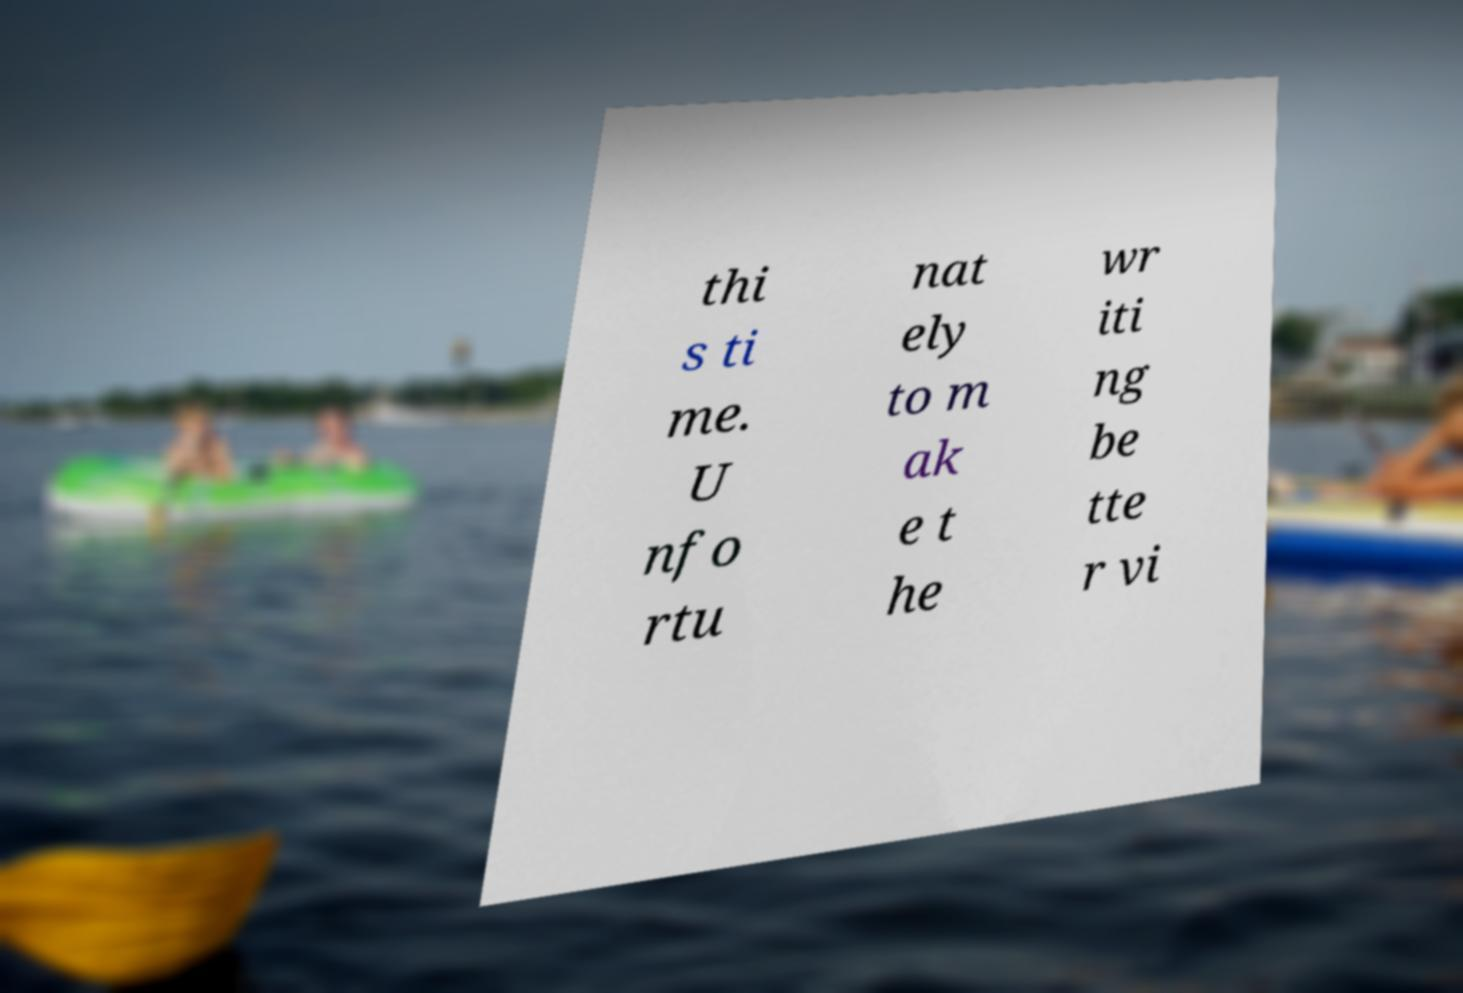Please identify and transcribe the text found in this image. thi s ti me. U nfo rtu nat ely to m ak e t he wr iti ng be tte r vi 